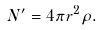Convert formula to latex. <formula><loc_0><loc_0><loc_500><loc_500>N ^ { \prime } = 4 \pi r ^ { 2 } \rho .</formula> 